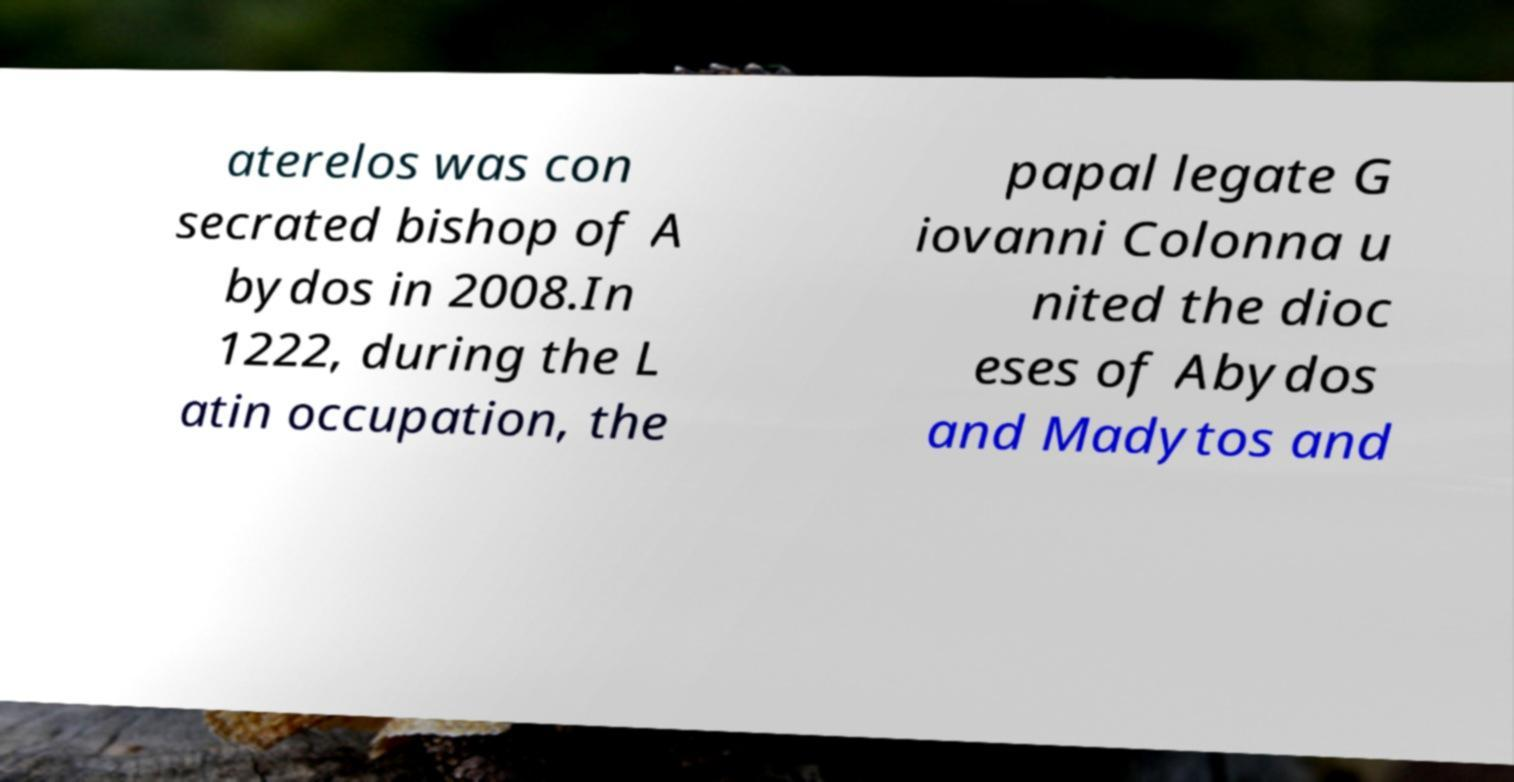Please identify and transcribe the text found in this image. aterelos was con secrated bishop of A bydos in 2008.In 1222, during the L atin occupation, the papal legate G iovanni Colonna u nited the dioc eses of Abydos and Madytos and 